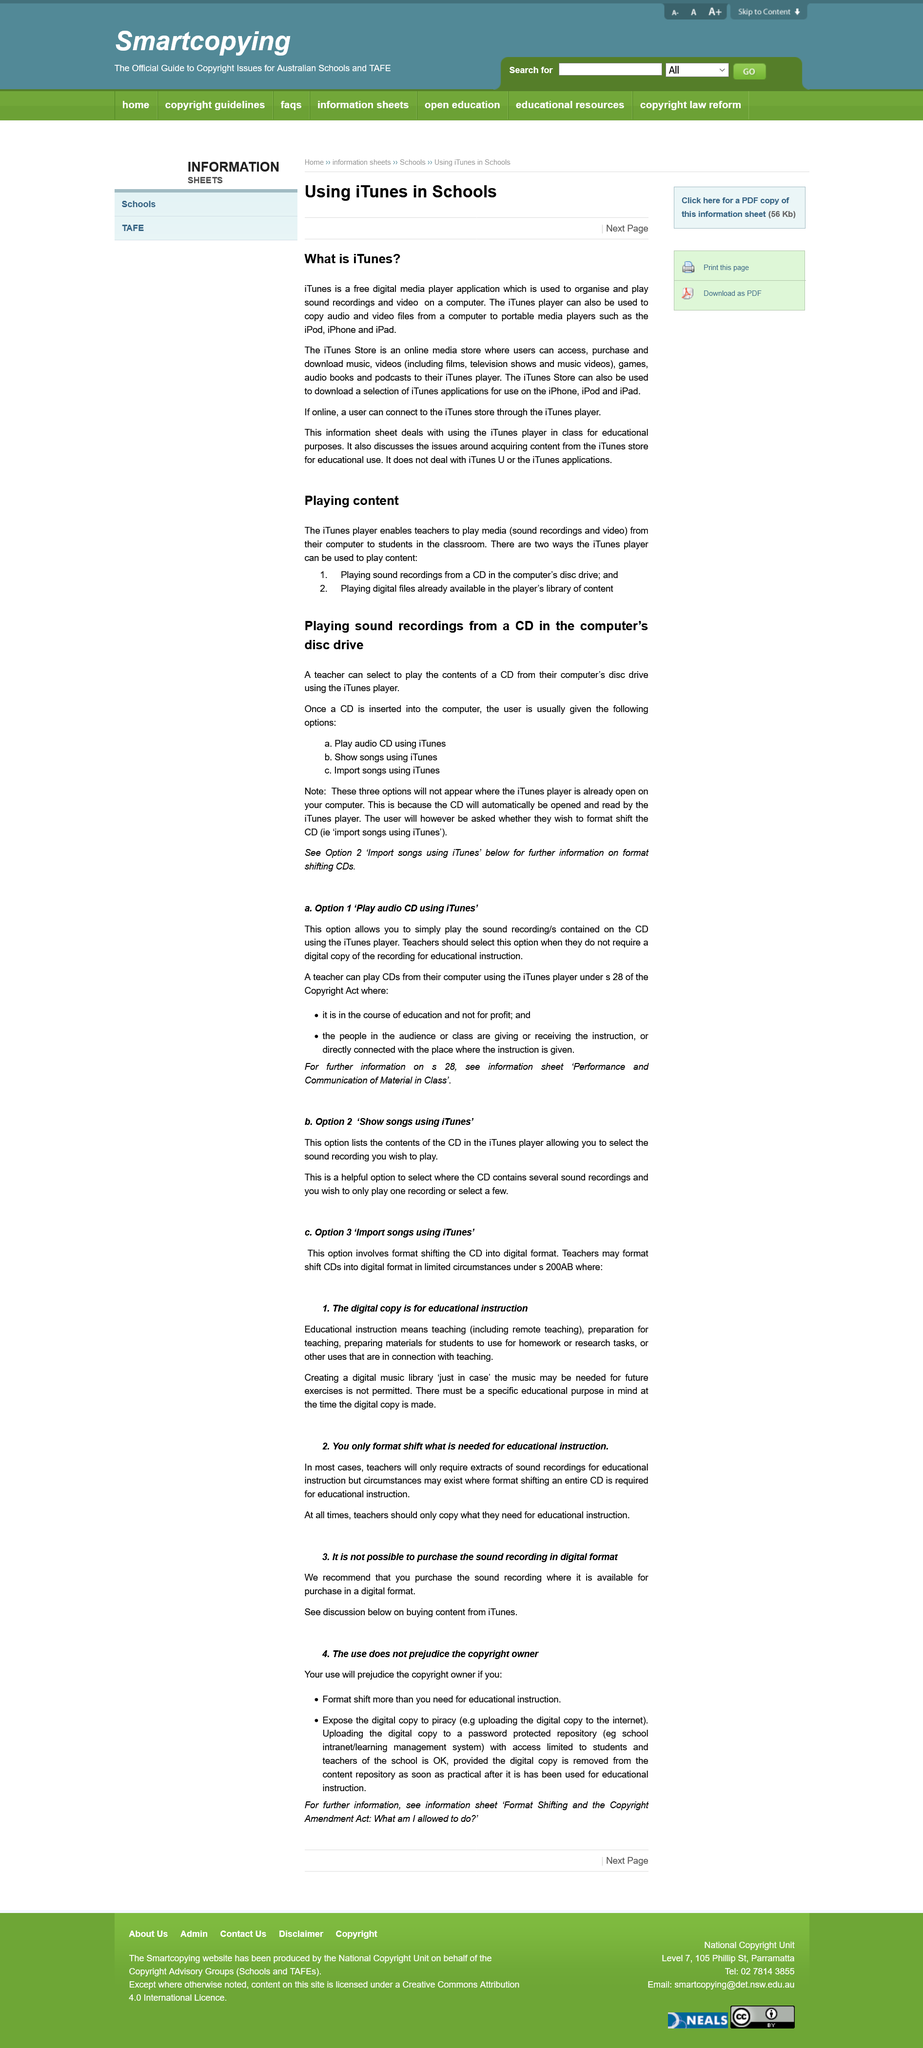List a handful of essential elements in this visual. The iTunes Store offers a variety of media that can be downloaded, including music, videos, games, books, podcasts, and the iTunes application. Teachers can only legally copy what is necessary for educational instruction. iTunes is a media player that can be used to play music, videos, and other media files, while the iTunes store is an online media store where users can purchase and download media content, such as music and movies, for playback on their devices. It is not permissible for a teacher to create a digital library, even if it may be useful in the future, as teachers are not authorized to do so. Yes, the user is able to import songs using iTunes. 